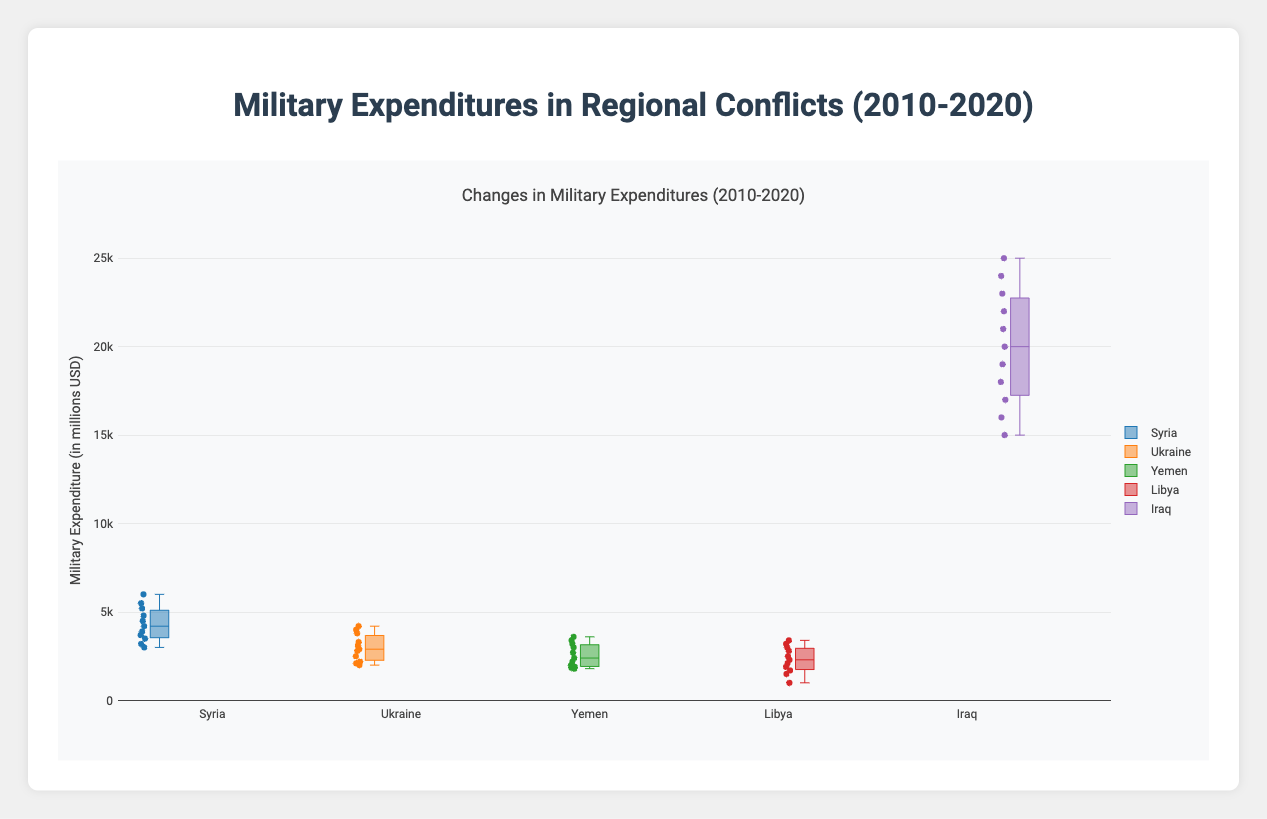What is the title of the figure? The title of a figure is typically at the top and in larger or bold font compared to the other text. In this case, it is "Military Expenditures in Regional Conflicts (2010-2020)."
Answer: Military Expenditures in Regional Conflicts (2010-2020) Which country has the highest military expenditure? We find the highest values in the figure and it's for Iraq, with expenditures reaching up to 25000 million USD.
Answer: Iraq Which country has the lowest median value in military expenditure? For each box plot, the median is represented by the line in the middle of the box. Libya has the lowest median value in military expenditure.
Answer: Libya What is the range of Syria's military expenditures between 2010 and 2020? The range is the difference between the maximum and minimum values in Syria's box plot. Syria's minimum is 3000 and maximum is 6000, so the range is 6000 - 3000.
Answer: 3000 How do Yemen's military expenditures trend over the years 2010 to 2020? By observing the box plot for Yemen, you can see a general upward trend in the military expenditures from the year 2010 to 2020, indicating increasing expenditures over time.
Answer: Upward trend Among the given countries, which one shows the most consistent military expenditure and why? Consistency can be judged by the spread of the box plot. A box with narrower whiskers and less spread between minimum and maximum values indicates more consistency. Yemen’s box plot shows the least amount of spread, indicating the most consistent military expenditure.
Answer: Yemen Compare the interquartile ranges (IQRs) of Syria and Ukraine. Which country has a larger IQR? The IQR is the distance between the first quartile (Q1) and the third quartile (Q3) in a box plot. By comparing the width of the boxes, Syria’s IQR appears clearly larger than Ukraine’s.
Answer: Syria Which country saw the highest increase in military expenditure from 2010 to 2020? By comparing the lowest and highest points of each box plot, the difference for Iraq is the largest, increasing from 15000 to 25000.
Answer: Iraq How do the military expenditures of Libya and Yemen compare in 2020? From the figure, both Libya and Yemen's expenditures in 2020 hover around the same range near 3400 million USD, indicating similar expenditures.
Answer: Similar Which country has the most outliers, and what might this imply? Outliers are indicated by individual points beyond the whiskers of a box plot. Ukraine has several such outliers, suggesting fluctuations or anomalies in its military expenditure during this period.
Answer: Ukraine 